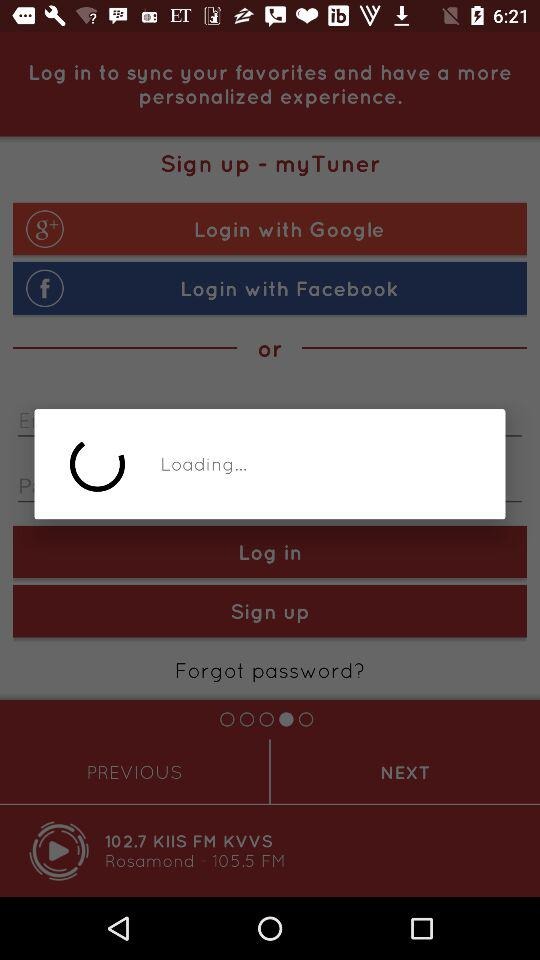What is the number of podcasts? The number is 1 million. 